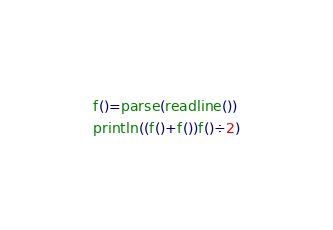Convert code to text. <code><loc_0><loc_0><loc_500><loc_500><_Julia_>f()=parse(readline())
println((f()+f())f()÷2)</code> 